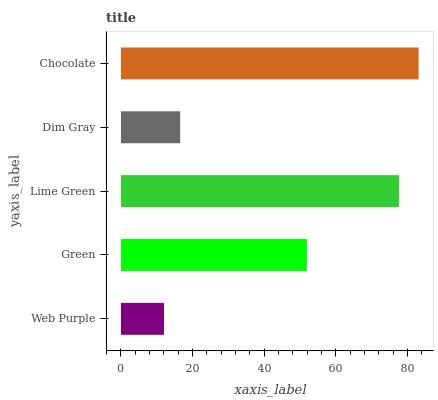Is Web Purple the minimum?
Answer yes or no. Yes. Is Chocolate the maximum?
Answer yes or no. Yes. Is Green the minimum?
Answer yes or no. No. Is Green the maximum?
Answer yes or no. No. Is Green greater than Web Purple?
Answer yes or no. Yes. Is Web Purple less than Green?
Answer yes or no. Yes. Is Web Purple greater than Green?
Answer yes or no. No. Is Green less than Web Purple?
Answer yes or no. No. Is Green the high median?
Answer yes or no. Yes. Is Green the low median?
Answer yes or no. Yes. Is Chocolate the high median?
Answer yes or no. No. Is Lime Green the low median?
Answer yes or no. No. 